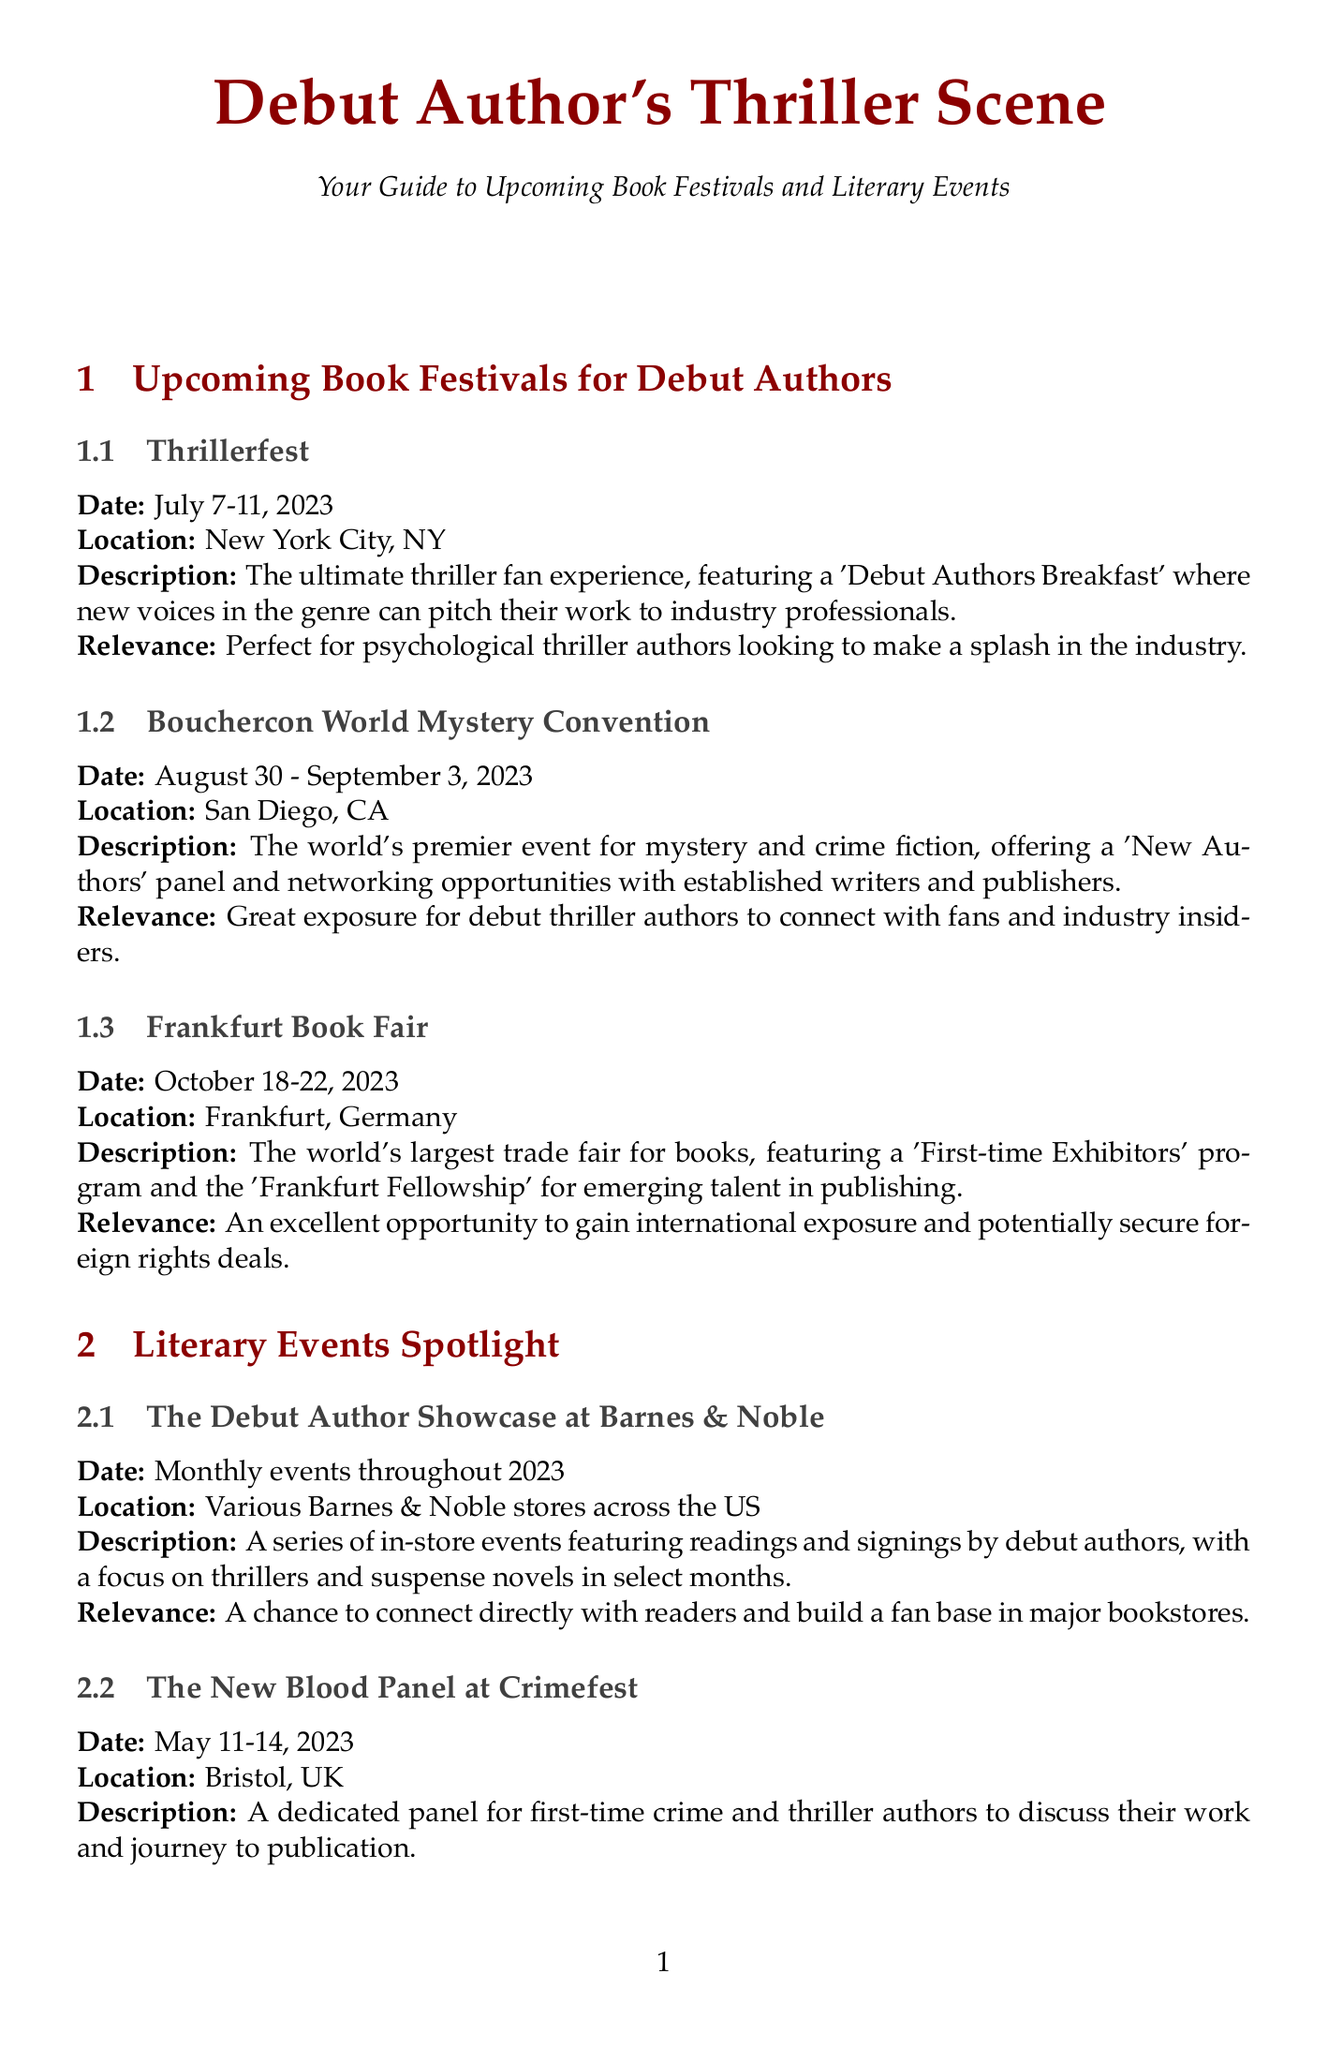What is the date of Thrillerfest? The date of Thrillerfest, as stated in the document, is July 7-11, 2023.
Answer: July 7-11, 2023 Where is the Bouchercon World Mystery Convention held? The document specifies that Bouchercon is located in San Diego, CA.
Answer: San Diego, CA What event is designed specifically for debut authors at the Frankfurt Book Fair? The document mentions the 'First-time Exhibitors' program as the opportunity for debut authors at the Frankfurt Book Fair.
Answer: First-time Exhibitors program What is the prize for winning the St. Martin's Minotaur competition? According to the document, the prize includes book publication and a $10,000 advance.
Answer: Book publication and $10,000 advance What type of events does the Debut Author Showcase at Barnes & Noble feature? The document describes the events as featuring readings and signings by debut authors.
Answer: Readings and signings Which online event specifically targets debut thriller authors? The document indicates that ThrillerCon Virtual includes a special track for debut novelists.
Answer: ThrillerCon Virtual How often are the Twitter Pitch Events held? The document mentions that the Twitter Pitch Events occur quarterly throughout 2023.
Answer: Quarterly What competitive event offers £500 as a prize? The document states that The Debut Dagger competition provides a prize of £500.
Answer: The Debut Dagger 